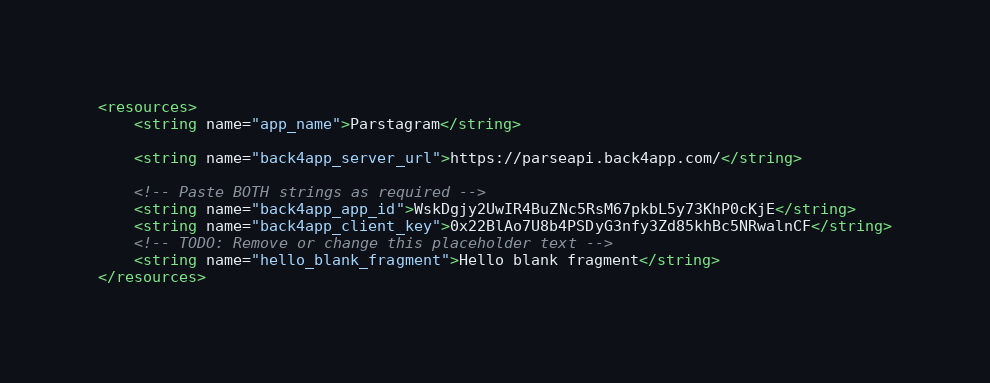Convert code to text. <code><loc_0><loc_0><loc_500><loc_500><_XML_><resources>
    <string name="app_name">Parstagram</string>

    <string name="back4app_server_url">https://parseapi.back4app.com/</string>

    <!-- Paste BOTH strings as required -->
    <string name="back4app_app_id">WskDgjy2UwIR4BuZNc5RsM67pkbL5y73KhP0cKjE</string>
    <string name="back4app_client_key">0x22BlAo7U8b4PSDyG3nfy3Zd85khBc5NRwalnCF</string>
    <!-- TODO: Remove or change this placeholder text -->
    <string name="hello_blank_fragment">Hello blank fragment</string>
</resources></code> 